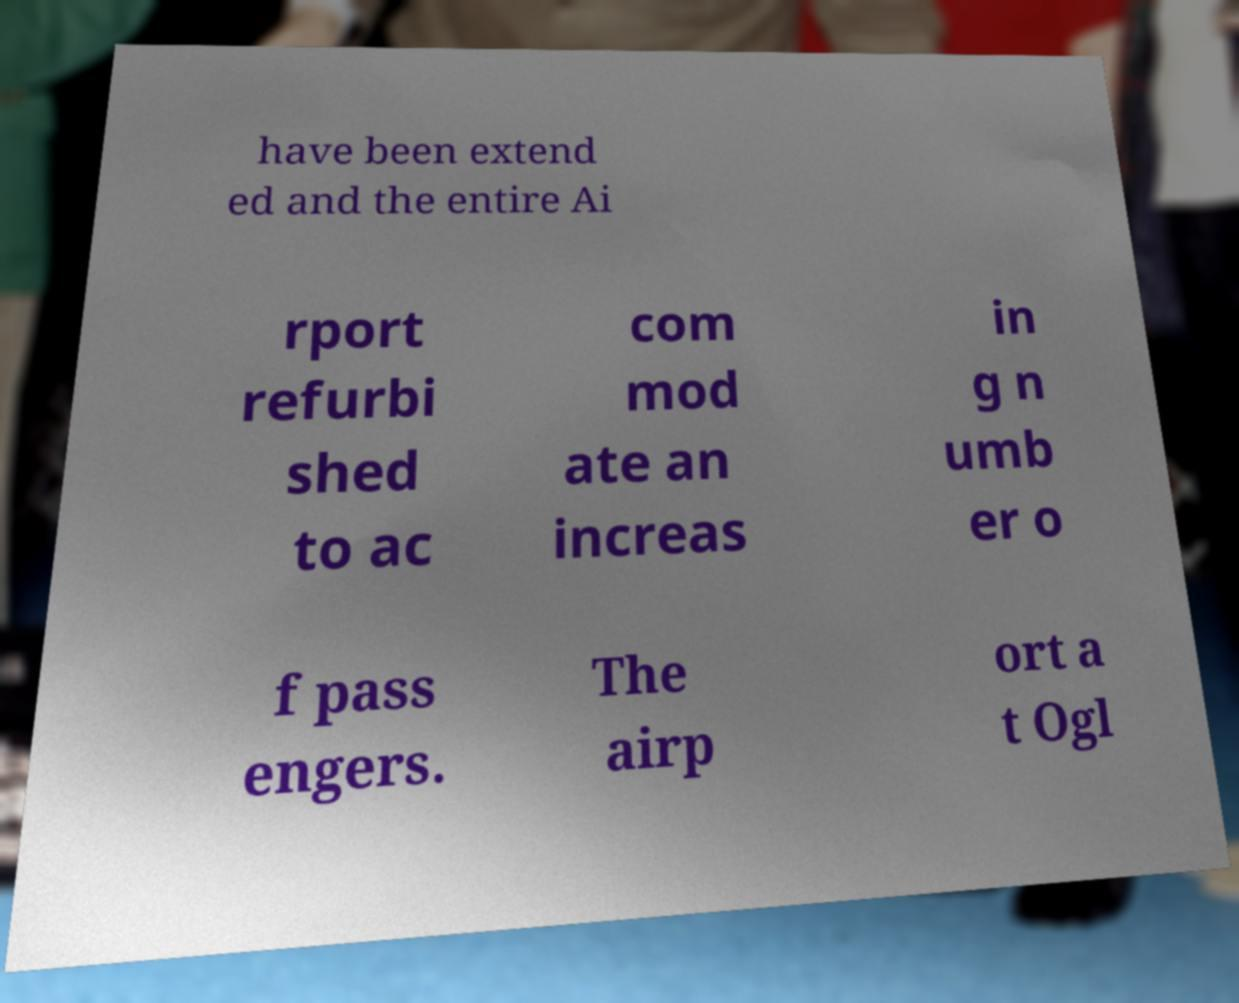Please identify and transcribe the text found in this image. have been extend ed and the entire Ai rport refurbi shed to ac com mod ate an increas in g n umb er o f pass engers. The airp ort a t Ogl 